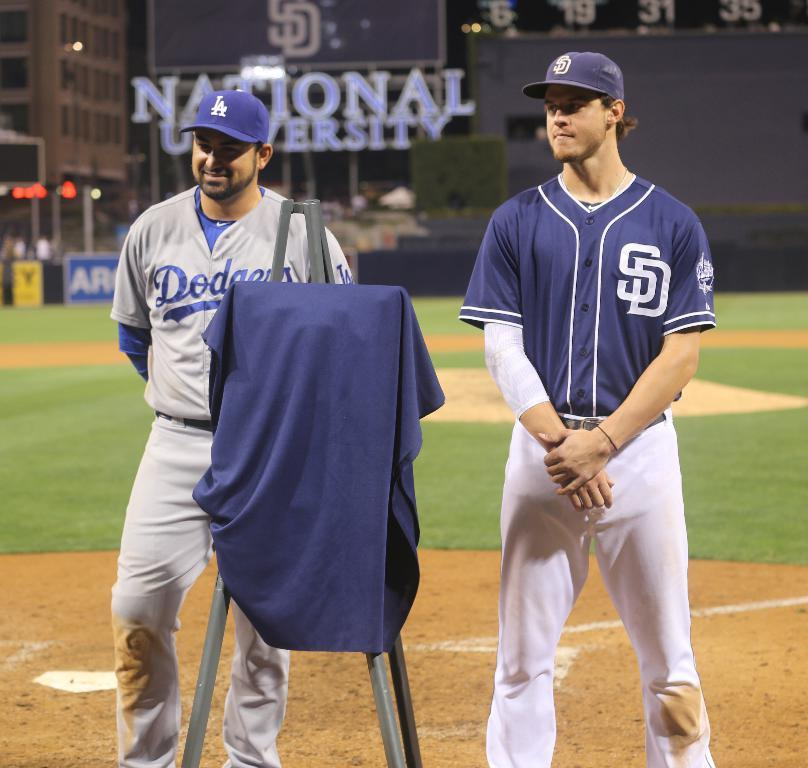<image>
Describe the image concisely. Two players for the Dodgers are standing on the field. 